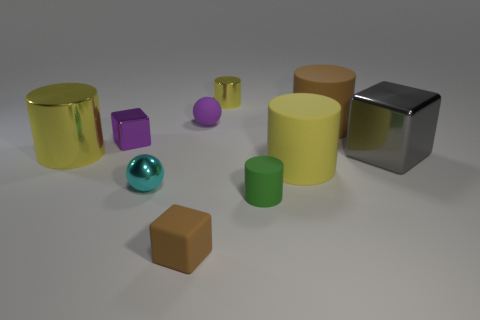Subtract all red blocks. How many yellow cylinders are left? 3 Subtract all shiny blocks. How many blocks are left? 1 Subtract 2 cylinders. How many cylinders are left? 3 Subtract all green cylinders. How many cylinders are left? 4 Subtract all balls. How many objects are left? 8 Subtract all brown cylinders. Subtract all red spheres. How many cylinders are left? 4 Add 4 balls. How many balls exist? 6 Subtract 0 green balls. How many objects are left? 10 Subtract all big green matte cylinders. Subtract all big yellow matte cylinders. How many objects are left? 9 Add 1 big rubber cylinders. How many big rubber cylinders are left? 3 